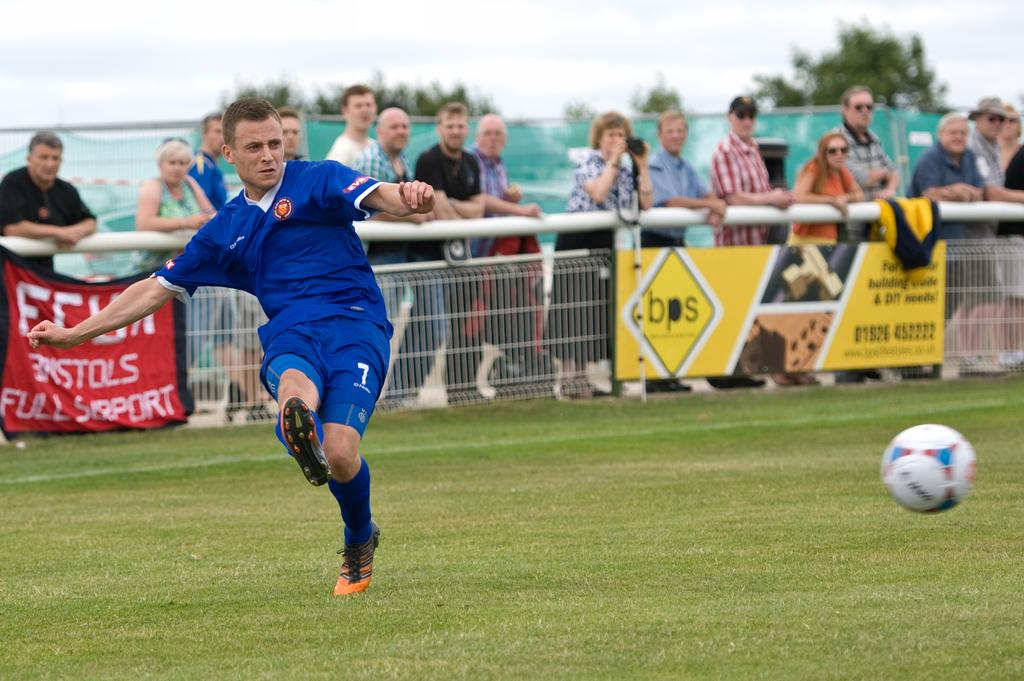<image>
Present a compact description of the photo's key features. A soccer game is in progress on a field with a bps advertisement on its fence. 